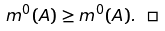<formula> <loc_0><loc_0><loc_500><loc_500>m ^ { 0 } ( A ) \geq m ^ { 0 } ( A ) . \ \square</formula> 